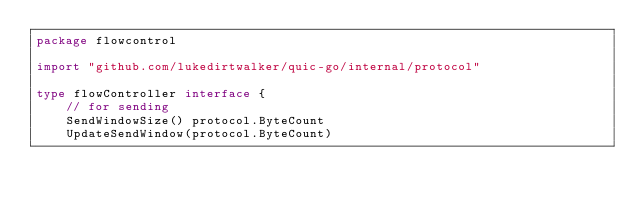<code> <loc_0><loc_0><loc_500><loc_500><_Go_>package flowcontrol

import "github.com/lukedirtwalker/quic-go/internal/protocol"

type flowController interface {
	// for sending
	SendWindowSize() protocol.ByteCount
	UpdateSendWindow(protocol.ByteCount)</code> 